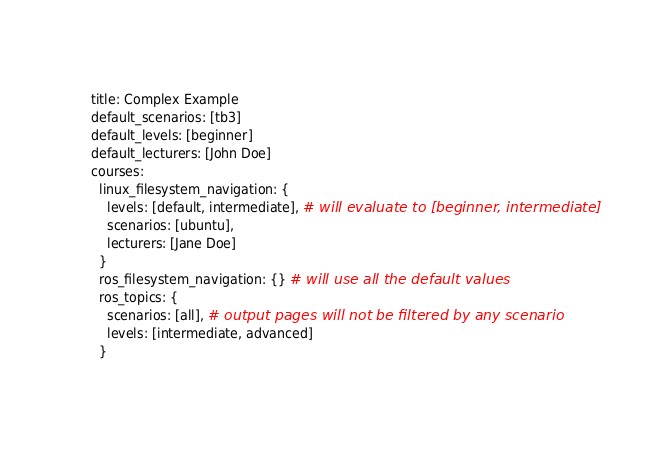Convert code to text. <code><loc_0><loc_0><loc_500><loc_500><_YAML_>title: Complex Example
default_scenarios: [tb3]
default_levels: [beginner]
default_lecturers: [John Doe]
courses:
  linux_filesystem_navigation: {
    levels: [default, intermediate], # will evaluate to [beginner, intermediate]
    scenarios: [ubuntu],
    lecturers: [Jane Doe]
  }
  ros_filesystem_navigation: {} # will use all the default values
  ros_topics: {
    scenarios: [all], # output pages will not be filtered by any scenario
    levels: [intermediate, advanced]
  }
</code> 